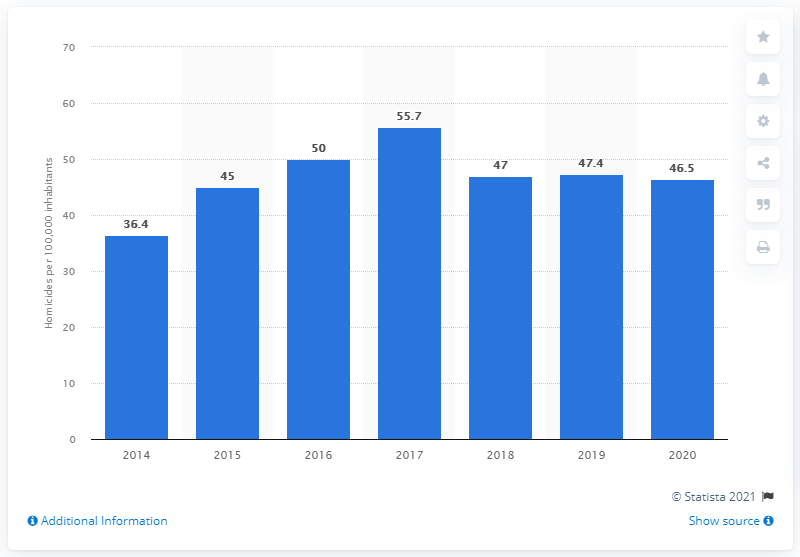Identify some key points in this picture. In 2020, Jamaica had approximately 46.5 homicides per 100,000 inhabitants. In 2019, the homicide rate in Jamaica was 47.4. 